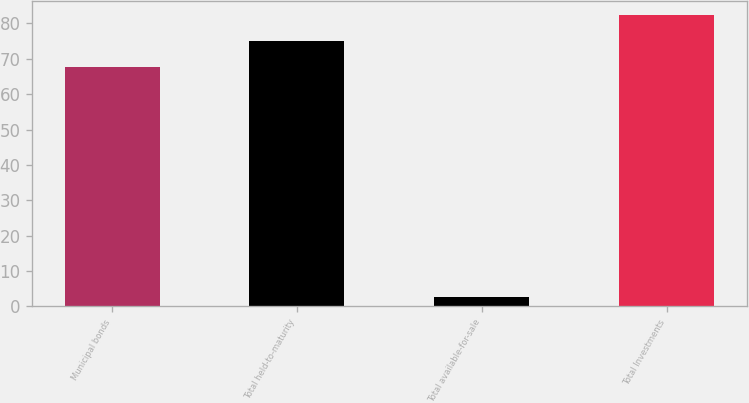<chart> <loc_0><loc_0><loc_500><loc_500><bar_chart><fcel>Municipal bonds<fcel>Total held-to-maturity<fcel>Total available-for-sale<fcel>Total Investments<nl><fcel>67.8<fcel>75.08<fcel>2.7<fcel>82.36<nl></chart> 